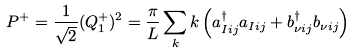Convert formula to latex. <formula><loc_0><loc_0><loc_500><loc_500>P ^ { + } = \frac { 1 } { \sqrt { 2 } } ( Q ^ { + } _ { 1 } ) ^ { 2 } = \frac { \pi } { L } \sum _ { k } k \left ( a _ { I i j } ^ { \dag } a _ { I i j } + b _ { \nu i j } ^ { \dag } b _ { \nu i j } \right )</formula> 